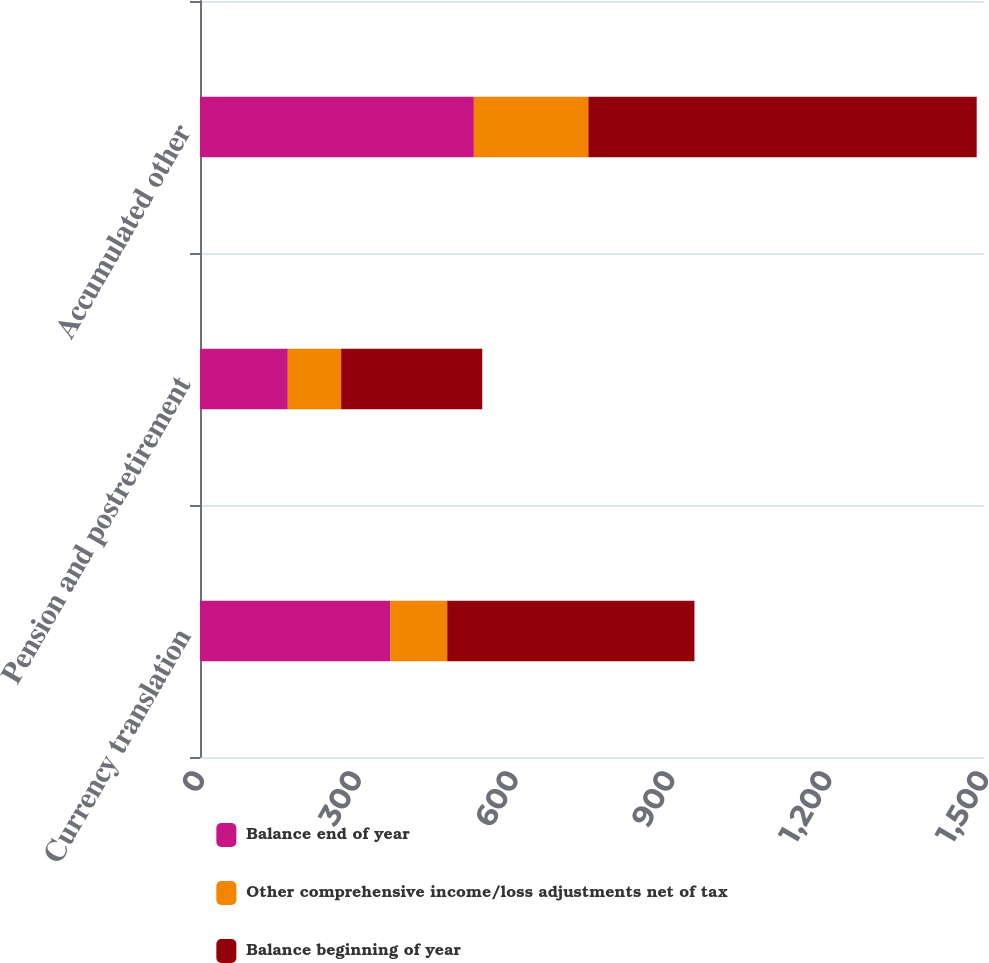<chart> <loc_0><loc_0><loc_500><loc_500><stacked_bar_chart><ecel><fcel>Currency translation<fcel>Pension and postretirement<fcel>Accumulated other<nl><fcel>Balance end of year<fcel>364<fcel>168<fcel>524<nl><fcel>Other comprehensive income/loss adjustments net of tax<fcel>109<fcel>102<fcel>219<nl><fcel>Balance beginning of year<fcel>473<fcel>270<fcel>743<nl></chart> 